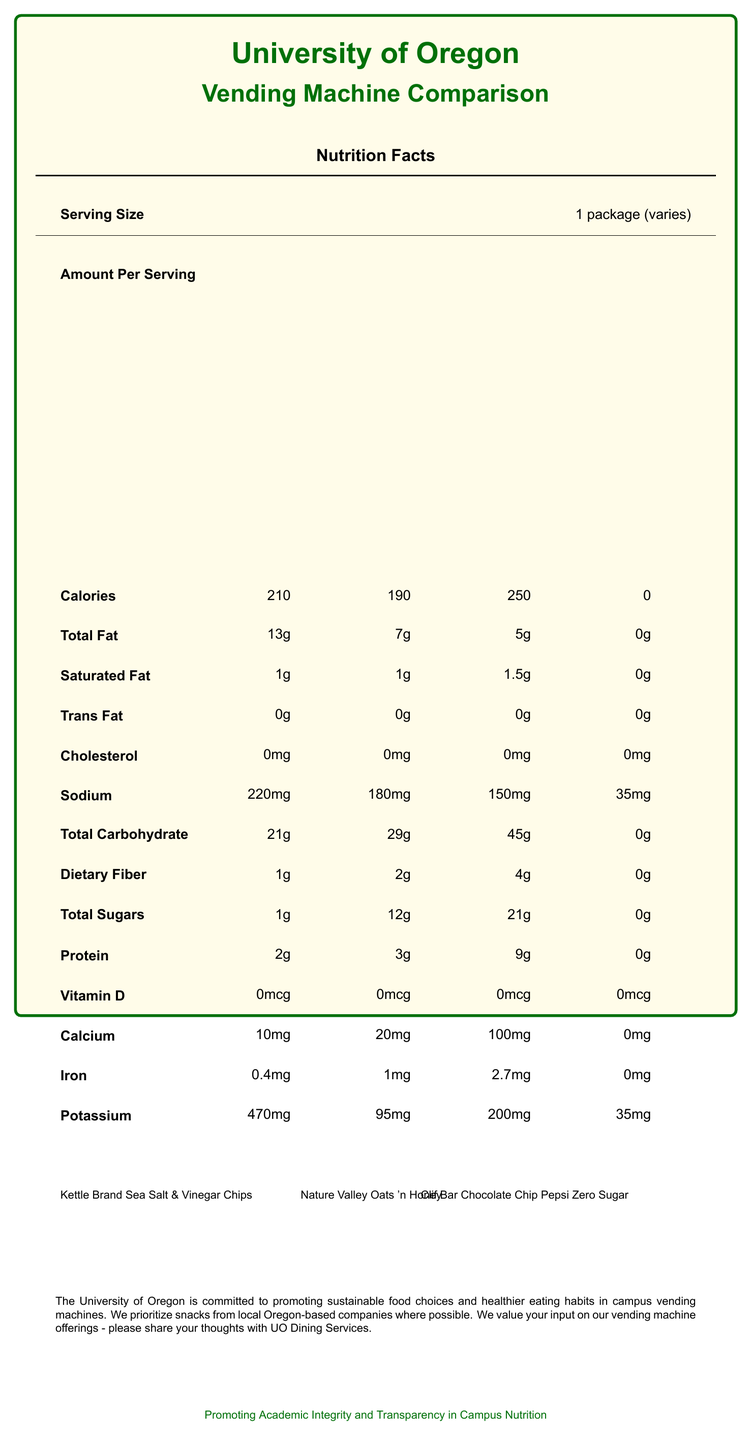what is the highest calorie count among the vending machine options? Clif Bar Chocolate Chip has the highest calorie count with 250 calories per serving.
Answer: 250 calories how many grams of total fat are in the Nature Valley Oats 'n Honey Granola Bar? The total fat content for the Nature Valley Oats 'n Honey Granola Bar is 7 grams per serving.
Answer: 7 grams which snack has the most dietary fiber? The Clif Bar Chocolate Chip has the most dietary fiber with 4 grams per serving.
Answer: Clif Bar Chocolate Chip what is the sodium content of Pepsi Zero Sugar? The sodium content of Pepsi Zero Sugar is 35 mg per serving.
Answer: 35 mg how much cholesterol is in Kettle Brand Sea Salt & Vinegar Chips? Kettle Brand Sea Salt & Vinegar Chips have 0 mg of cholesterol per serving.
Answer: 0 mg which option has the least total carbohydrates? A. Kettle Brand Sea Salt & Vinegar Chips B. Nature Valley Oats 'n Honey Granola Bar C. Clif Bar Chocolate Chip D. Pepsi Zero Sugar Pepsi Zero Sugar has 0 grams of total carbohydrates, which is less than the other options.
Answer: D. Pepsi Zero Sugar which product contains the highest amount of iron? A. Kettle Brand Sea Salt & Vinegar Chips B. Nature Valley Oats 'n Honey Granola Bar C. Clif Bar Chocolate Chip D. Pepsi Zero Sugar The Clif Bar Chocolate Chip contains 2.7 mg of iron, which is higher than the other options.
Answer: C. Clif Bar Chocolate Chip Do any of the snacks have trans fat? None of the listed snacks have trans fat as indicated by all entries showing 0 grams of trans fat.
Answer: No describe the main idea of this document. The document provides detailed nutritional information for four vending machine snacks, including Kettle Brand Sea Salt & Vinegar Chips, Nature Valley Oats 'n Honey Granola Bar, Clif Bar Chocolate Chip, and Pepsi Zero Sugar. It emphasizes the university's efforts to offer sustainable, healthy, and locally sourced food options on campus.
Answer: The document is a nutrition facts comparison of four vending machine options available at the University of Oregon. It includes information on calories, fats, cholesterol, sodium, carbohydrates, dietary fiber, sugars, protein, vitamins, and minerals for each product. Additionally, the document highlights the university's commitment to promoting sustainable and healthier food choices, local sourcing, and encouraging feedback from the university community. what is the sustainability message in the document? The document mentions that the University of Oregon is committed to promoting sustainable food choices in campus vending machines.
Answer: Promoting sustainable food choices what are the allergen details for Clif Bar Chocolate Chip? The allergen information for Clif Bar Chocolate Chip indicates it contains soy and may contain traces of peanuts, tree nuts, and milk.
Answer: Contains soy; may contain traces of peanuts, tree nuts, and milk what is the potassium content in the Nature Valley Oats 'n Honey Granola Bar? The potassium content in the Nature Valley Oats 'n Honey Granola Bar is 95 mg per serving.
Answer: 95 mg which product has the lowest protein content? Pepsi Zero Sugar has 0 grams of protein, making it the lowest among the options.
Answer: Pepsi Zero Sugar how many products have an iron content of 1 mg or more? Both the Nature Valley Oats 'n Honey Granola Bar (1 mg) and Clif Bar Chocolate Chip (2.7 mg) have an iron content of 1 mg or more.
Answer: 2 products which of the listed snacks are locally sourced from Oregon? The document states that the University of Oregon prioritizes locally sourced snacks but does not specify which of the listed snacks are from Oregon-based companies.
Answer: Not enough information 